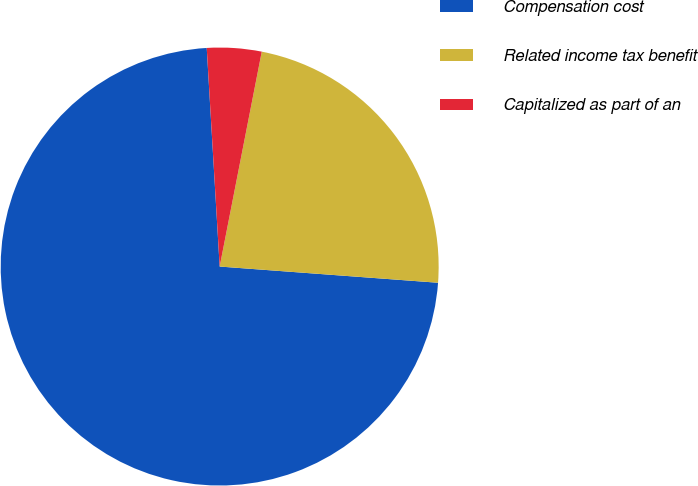<chart> <loc_0><loc_0><loc_500><loc_500><pie_chart><fcel>Compensation cost<fcel>Related income tax benefit<fcel>Capitalized as part of an<nl><fcel>72.88%<fcel>23.1%<fcel>4.02%<nl></chart> 